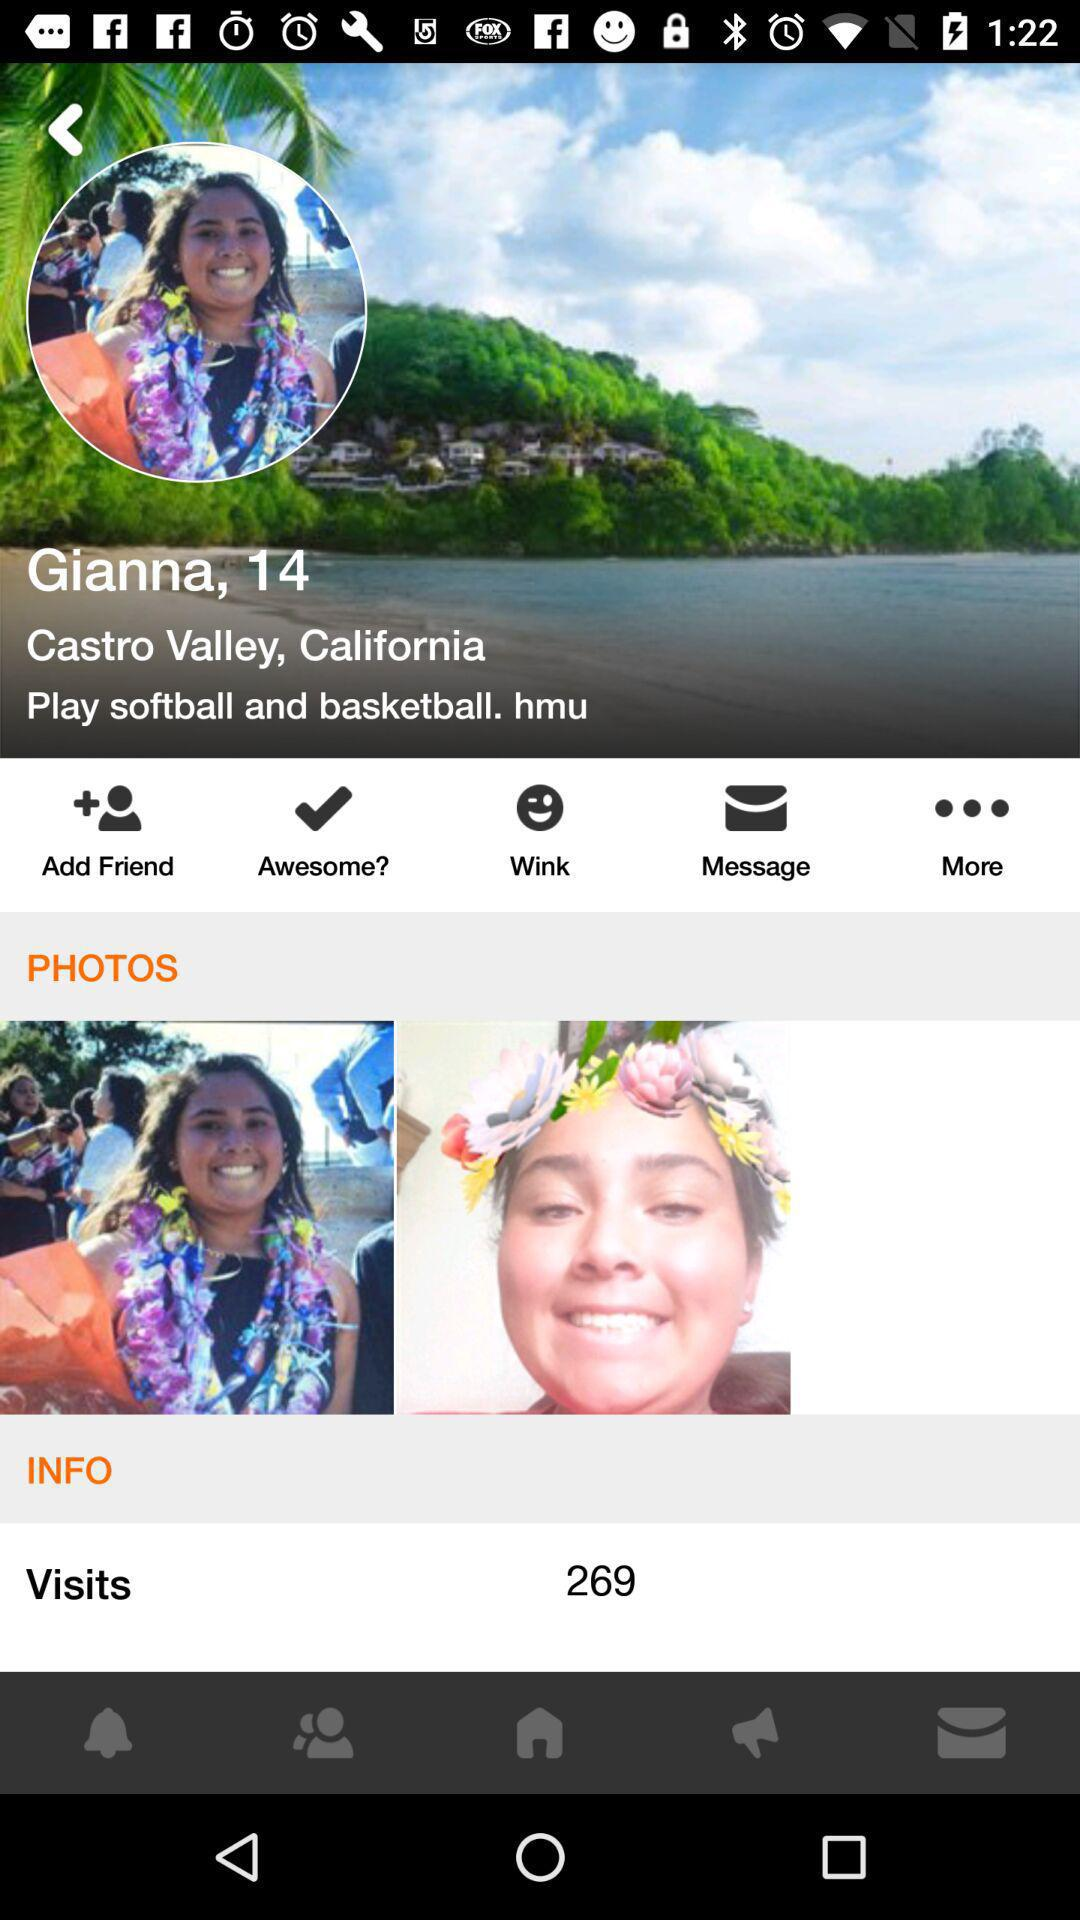What is the location? The location is Castro Valley, California. 